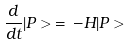Convert formula to latex. <formula><loc_0><loc_0><loc_500><loc_500>\frac { d } { d t } | P > \, = \, - H | P ></formula> 